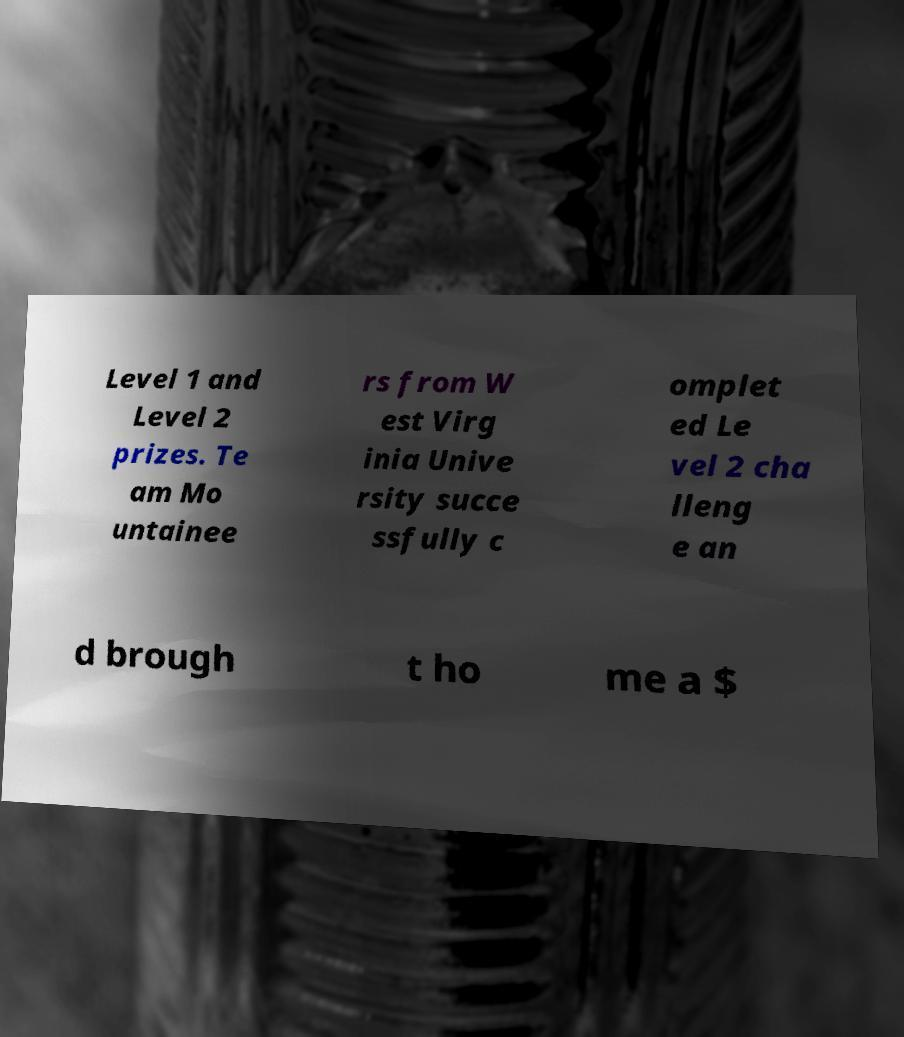Can you accurately transcribe the text from the provided image for me? Level 1 and Level 2 prizes. Te am Mo untainee rs from W est Virg inia Unive rsity succe ssfully c omplet ed Le vel 2 cha lleng e an d brough t ho me a $ 